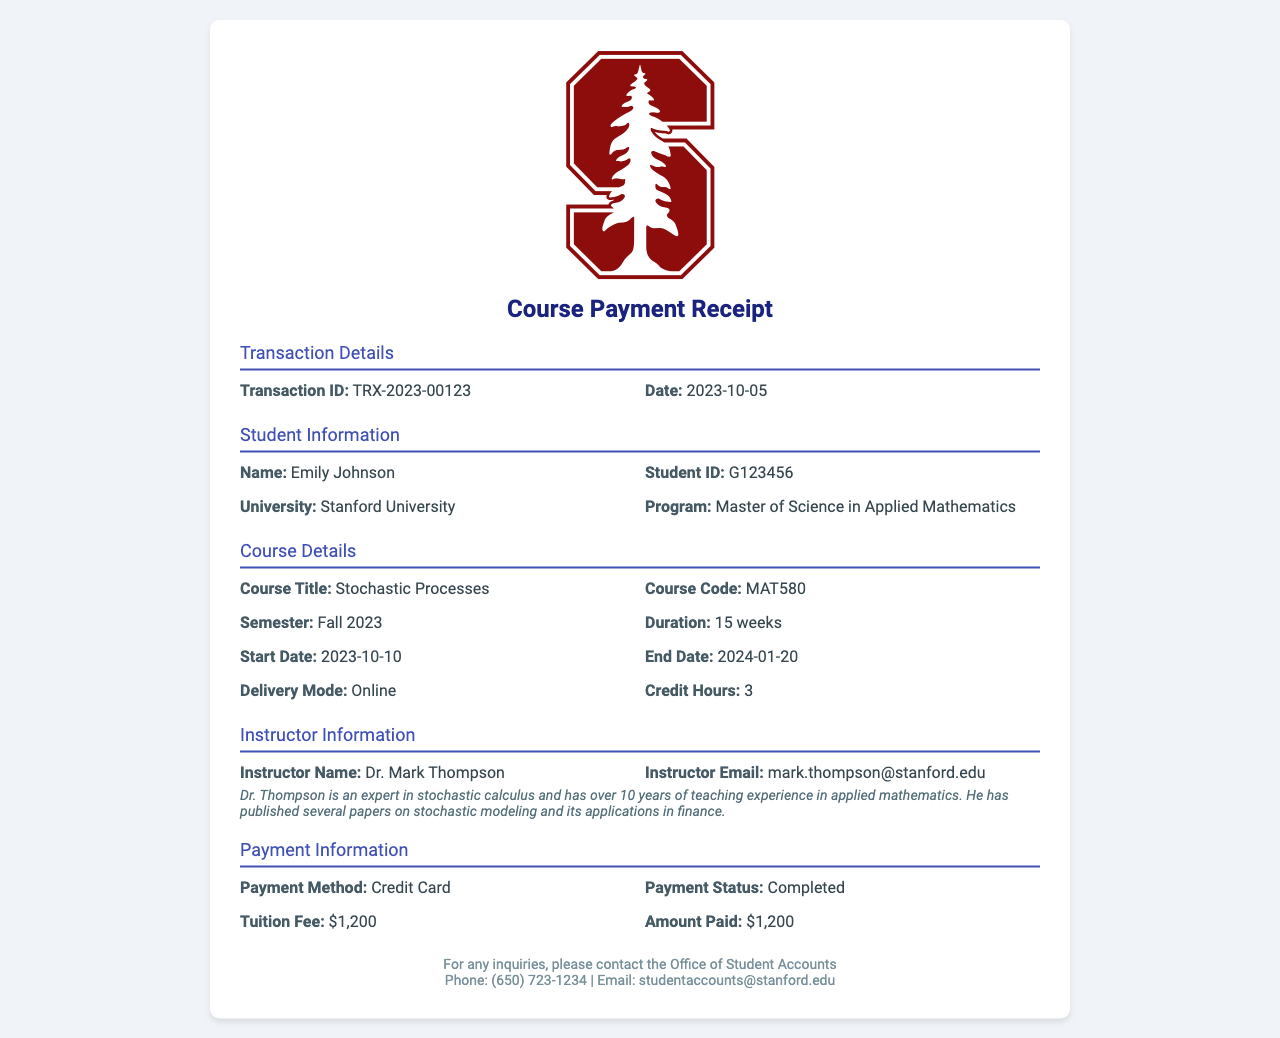what is the course title? The course title is listed in the Course Details section of the document.
Answer: Stochastic Processes who is the instructor? The instructor's name is found under the Instructor Information section.
Answer: Dr. Mark Thompson what is the transaction ID? The transaction ID can be found in the Transaction Details section.
Answer: TRX-2023-00123 when does the course start? The start date of the course is provided in the Course Details section.
Answer: 2023-10-10 how much is the tuition fee? The tuition fee is specified in the Payment Information section of the document.
Answer: $1,200 what is the delivery mode of the course? The delivery mode is mentioned in the Course Details section.
Answer: Online how many credit hours is the course worth? The number of credit hours is indicated in the Course Details area.
Answer: 3 what is the payment status? The payment status can be found in the Payment Information section.
Answer: Completed what is the email of the instructor? The instructor's email is listed under the Instructor Information section of the document.
Answer: mark.thompson@stanford.edu 